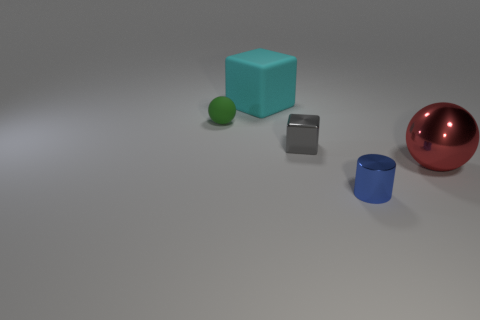Is there any other thing that has the same material as the cyan cube?
Give a very brief answer. Yes. Are there any small blue metallic things that have the same shape as the small gray metallic object?
Your answer should be very brief. No. Is the material of the small sphere the same as the ball to the right of the small matte object?
Ensure brevity in your answer.  No. There is a large thing that is right of the small metallic object that is behind the small shiny cylinder; what is its material?
Your answer should be very brief. Metal. Are there more small metal objects that are left of the small blue metal object than large red shiny cylinders?
Provide a short and direct response. Yes. Are there any metallic cylinders?
Your answer should be very brief. Yes. What color is the tiny cylinder that is in front of the small ball?
Your answer should be very brief. Blue. What is the material of the cube that is the same size as the green object?
Your answer should be compact. Metal. What number of other things are there of the same material as the green sphere
Ensure brevity in your answer.  1. What is the color of the small thing that is both to the right of the cyan matte cube and on the left side of the tiny blue object?
Your answer should be very brief. Gray. 